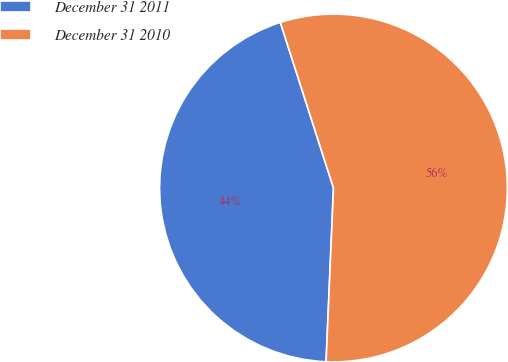<chart> <loc_0><loc_0><loc_500><loc_500><pie_chart><fcel>December 31 2011<fcel>December 31 2010<nl><fcel>44.38%<fcel>55.62%<nl></chart> 